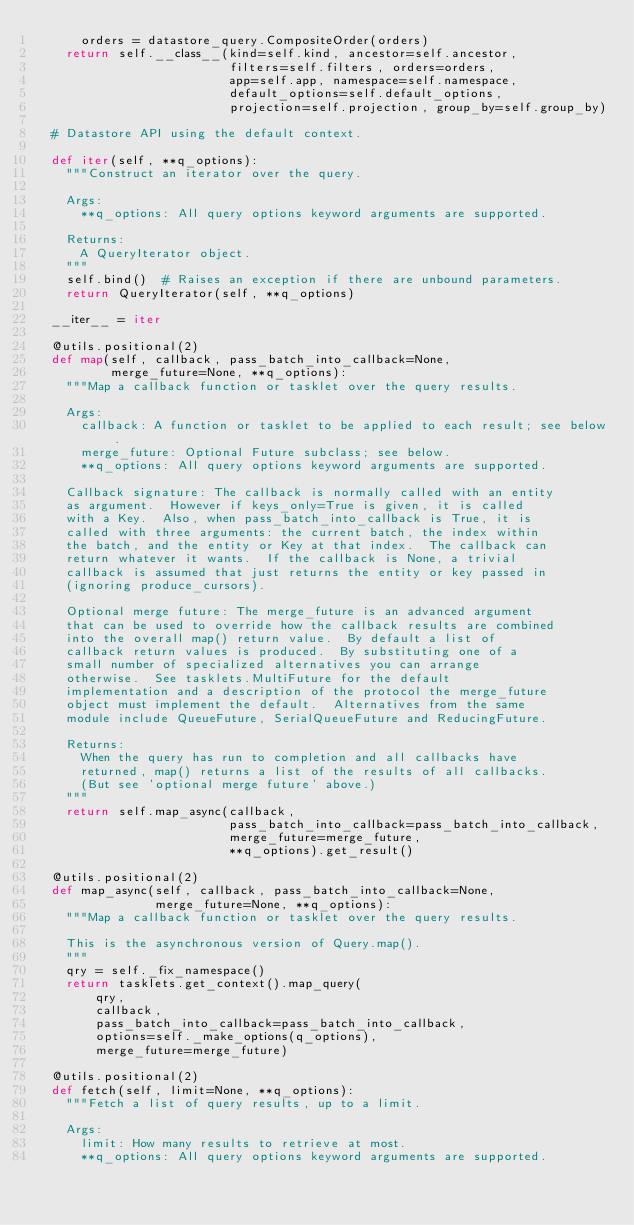<code> <loc_0><loc_0><loc_500><loc_500><_Python_>      orders = datastore_query.CompositeOrder(orders)
    return self.__class__(kind=self.kind, ancestor=self.ancestor,
                          filters=self.filters, orders=orders,
                          app=self.app, namespace=self.namespace,
                          default_options=self.default_options,
                          projection=self.projection, group_by=self.group_by)

  # Datastore API using the default context.

  def iter(self, **q_options):
    """Construct an iterator over the query.

    Args:
      **q_options: All query options keyword arguments are supported.

    Returns:
      A QueryIterator object.
    """
    self.bind()  # Raises an exception if there are unbound parameters.
    return QueryIterator(self, **q_options)

  __iter__ = iter

  @utils.positional(2)
  def map(self, callback, pass_batch_into_callback=None,
          merge_future=None, **q_options):
    """Map a callback function or tasklet over the query results.

    Args:
      callback: A function or tasklet to be applied to each result; see below.
      merge_future: Optional Future subclass; see below.
      **q_options: All query options keyword arguments are supported.

    Callback signature: The callback is normally called with an entity
    as argument.  However if keys_only=True is given, it is called
    with a Key.  Also, when pass_batch_into_callback is True, it is
    called with three arguments: the current batch, the index within
    the batch, and the entity or Key at that index.  The callback can
    return whatever it wants.  If the callback is None, a trivial
    callback is assumed that just returns the entity or key passed in
    (ignoring produce_cursors).

    Optional merge future: The merge_future is an advanced argument
    that can be used to override how the callback results are combined
    into the overall map() return value.  By default a list of
    callback return values is produced.  By substituting one of a
    small number of specialized alternatives you can arrange
    otherwise.  See tasklets.MultiFuture for the default
    implementation and a description of the protocol the merge_future
    object must implement the default.  Alternatives from the same
    module include QueueFuture, SerialQueueFuture and ReducingFuture.

    Returns:
      When the query has run to completion and all callbacks have
      returned, map() returns a list of the results of all callbacks.
      (But see 'optional merge future' above.)
    """
    return self.map_async(callback,
                          pass_batch_into_callback=pass_batch_into_callback,
                          merge_future=merge_future,
                          **q_options).get_result()

  @utils.positional(2)
  def map_async(self, callback, pass_batch_into_callback=None,
                merge_future=None, **q_options):
    """Map a callback function or tasklet over the query results.

    This is the asynchronous version of Query.map().
    """
    qry = self._fix_namespace()
    return tasklets.get_context().map_query(
        qry,
        callback,
        pass_batch_into_callback=pass_batch_into_callback,
        options=self._make_options(q_options),
        merge_future=merge_future)

  @utils.positional(2)
  def fetch(self, limit=None, **q_options):
    """Fetch a list of query results, up to a limit.

    Args:
      limit: How many results to retrieve at most.
      **q_options: All query options keyword arguments are supported.
</code> 